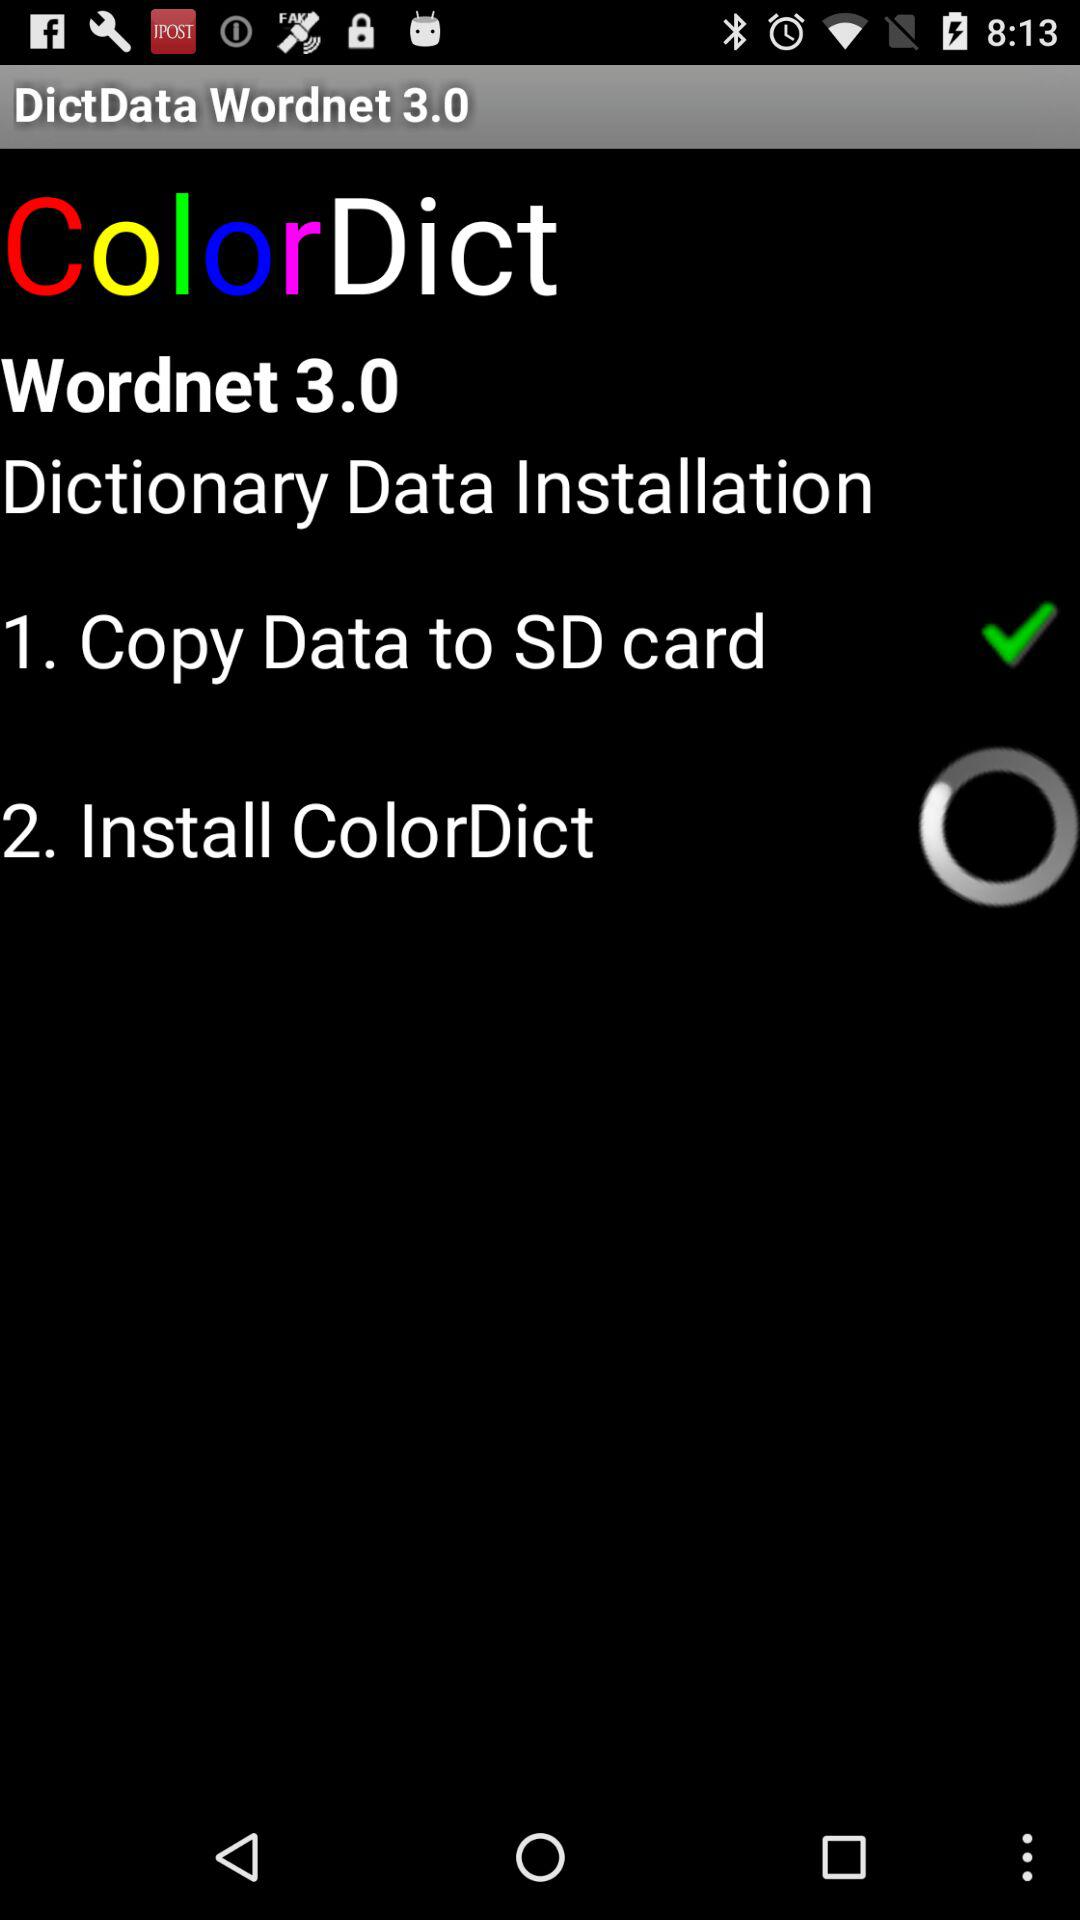How many steps are there in the Dictionary Data Installation process?
Answer the question using a single word or phrase. 2 